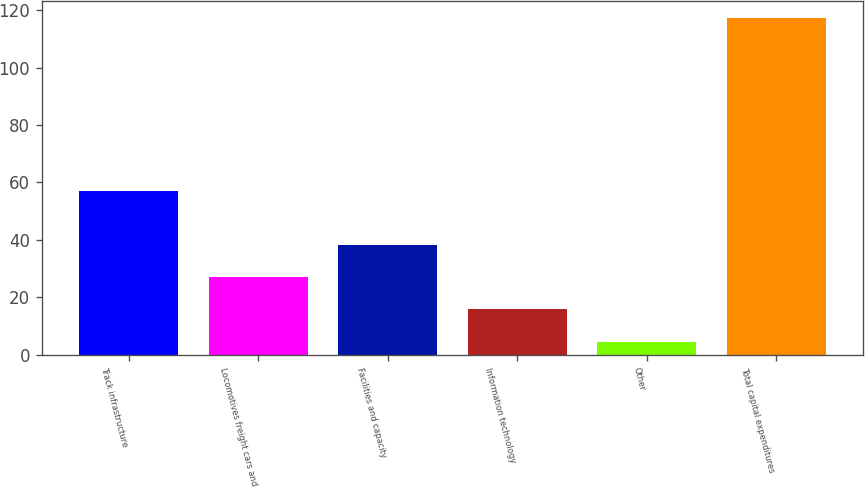Convert chart to OTSL. <chart><loc_0><loc_0><loc_500><loc_500><bar_chart><fcel>Track infrastructure<fcel>Locomotives freight cars and<fcel>Facilities and capacity<fcel>Information technology<fcel>Other<fcel>Total capital expenditures<nl><fcel>57.2<fcel>27.12<fcel>38.38<fcel>15.86<fcel>4.6<fcel>117.2<nl></chart> 